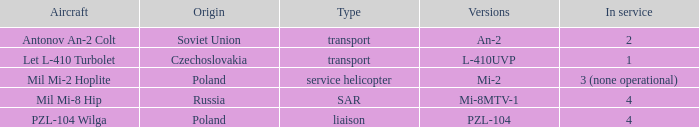Provide the editions for czechoslovakia. L-410UVP. Would you mind parsing the complete table? {'header': ['Aircraft', 'Origin', 'Type', 'Versions', 'In service'], 'rows': [['Antonov An-2 Colt', 'Soviet Union', 'transport', 'An-2', '2'], ['Let L-410 Turbolet', 'Czechoslovakia', 'transport', 'L-410UVP', '1'], ['Mil Mi-2 Hoplite', 'Poland', 'service helicopter', 'Mi-2', '3 (none operational)'], ['Mil Mi-8 Hip', 'Russia', 'SAR', 'Mi-8MTV-1', '4'], ['PZL-104 Wilga', 'Poland', 'liaison', 'PZL-104', '4']]} 